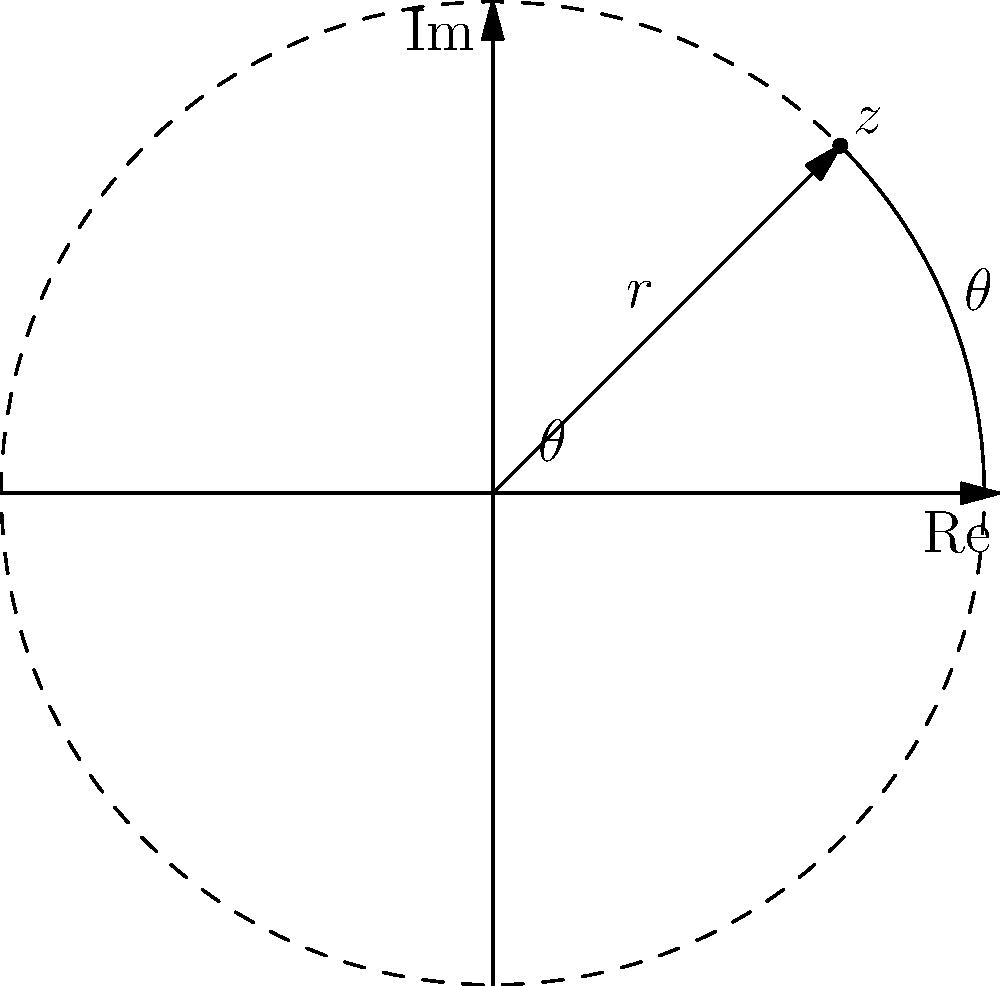A complex number $z$ is given in rectangular form as $z = 2 + 2i$. Convert this complex number to polar form and visualize it on the complex plane. What is the magnitude (modulus) of $z$ and its argument (angle) in radians? To convert a complex number from rectangular form $(a + bi)$ to polar form $(r(\cos\theta + i\sin\theta))$, we need to find the magnitude $r$ and the argument $\theta$.

Step 1: Calculate the magnitude $r$
$r = \sqrt{a^2 + b^2} = \sqrt{2^2 + 2^2} = \sqrt{8} = 2\sqrt{2} \approx 2.83$

Step 2: Calculate the argument $\theta$
$\theta = \arctan(\frac{b}{a}) = \arctan(\frac{2}{2}) = \arctan(1) = \frac{\pi}{4}$

Step 3: Express $z$ in polar form
$z = r(\cos\theta + i\sin\theta) = 2\sqrt{2}(\cos\frac{\pi}{4} + i\sin\frac{\pi}{4})$

Step 4: Visualize on the complex plane
The complex number $z$ is represented by a point on the complex plane. The magnitude $r$ is the distance from the origin to this point, and the argument $\theta$ is the angle between the positive real axis and the line from the origin to the point.

In this case, the point is located at $(2, 2)$ on the complex plane, which corresponds to a magnitude of $2\sqrt{2}$ and an angle of $\frac{\pi}{4}$ radians (45 degrees) from the positive real axis.
Answer: Magnitude: $2\sqrt{2}$, Argument: $\frac{\pi}{4}$ radians 